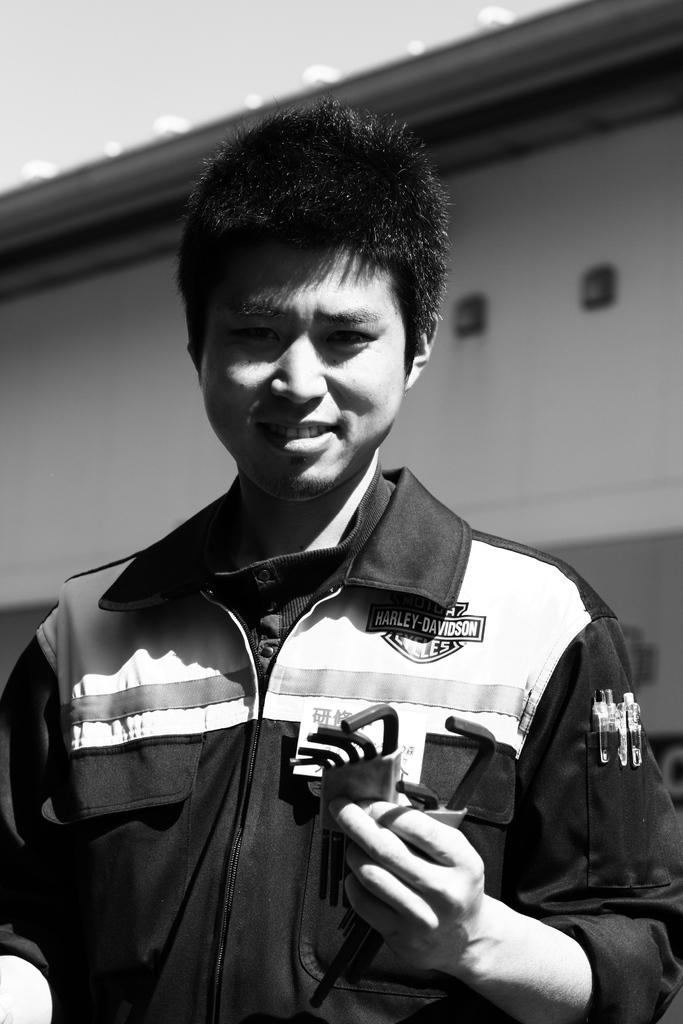What is the color scheme of the image? The image is black and white. Can you describe the main subject in the image? There is a person in the image. What is the person wearing? The person is wearing clothes. What is the person doing with his hands? The person is holding objects with his hands. What can be seen in the background of the image? There is a wall in the background of the image. How many goldfish are swimming in the image? There are no goldfish present in the image. What is the level of noise in the image? The image is black and white and does not convey any information about the level of noise. 